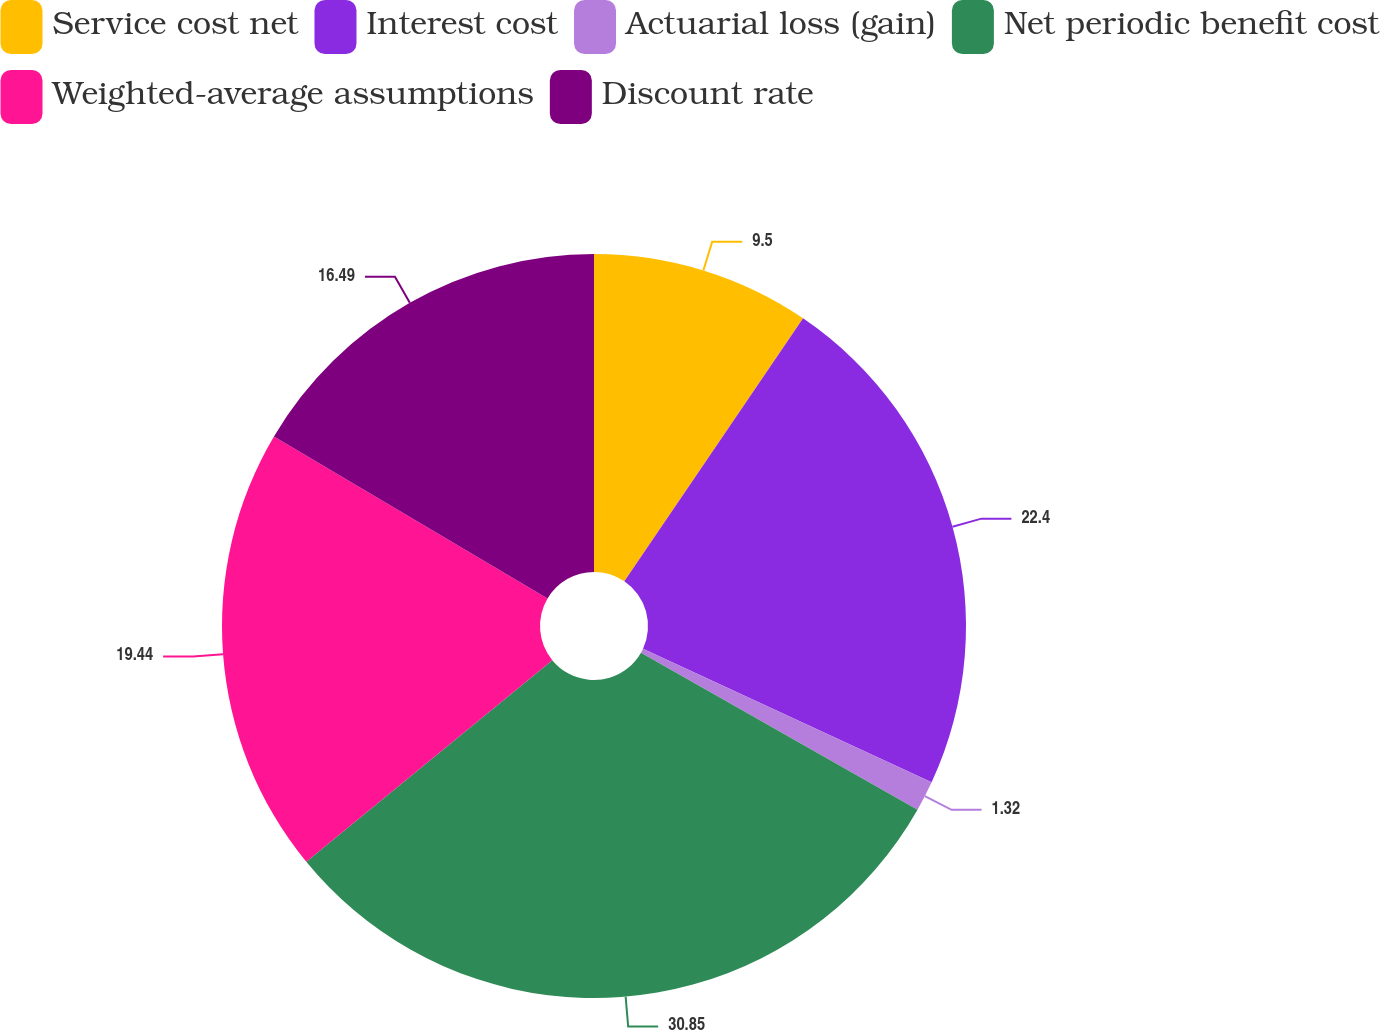Convert chart to OTSL. <chart><loc_0><loc_0><loc_500><loc_500><pie_chart><fcel>Service cost net<fcel>Interest cost<fcel>Actuarial loss (gain)<fcel>Net periodic benefit cost<fcel>Weighted-average assumptions<fcel>Discount rate<nl><fcel>9.5%<fcel>22.4%<fcel>1.32%<fcel>30.86%<fcel>19.44%<fcel>16.49%<nl></chart> 